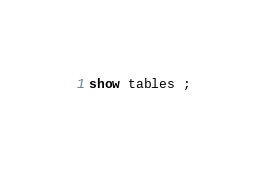<code> <loc_0><loc_0><loc_500><loc_500><_SQL_>show tables ;
</code> 